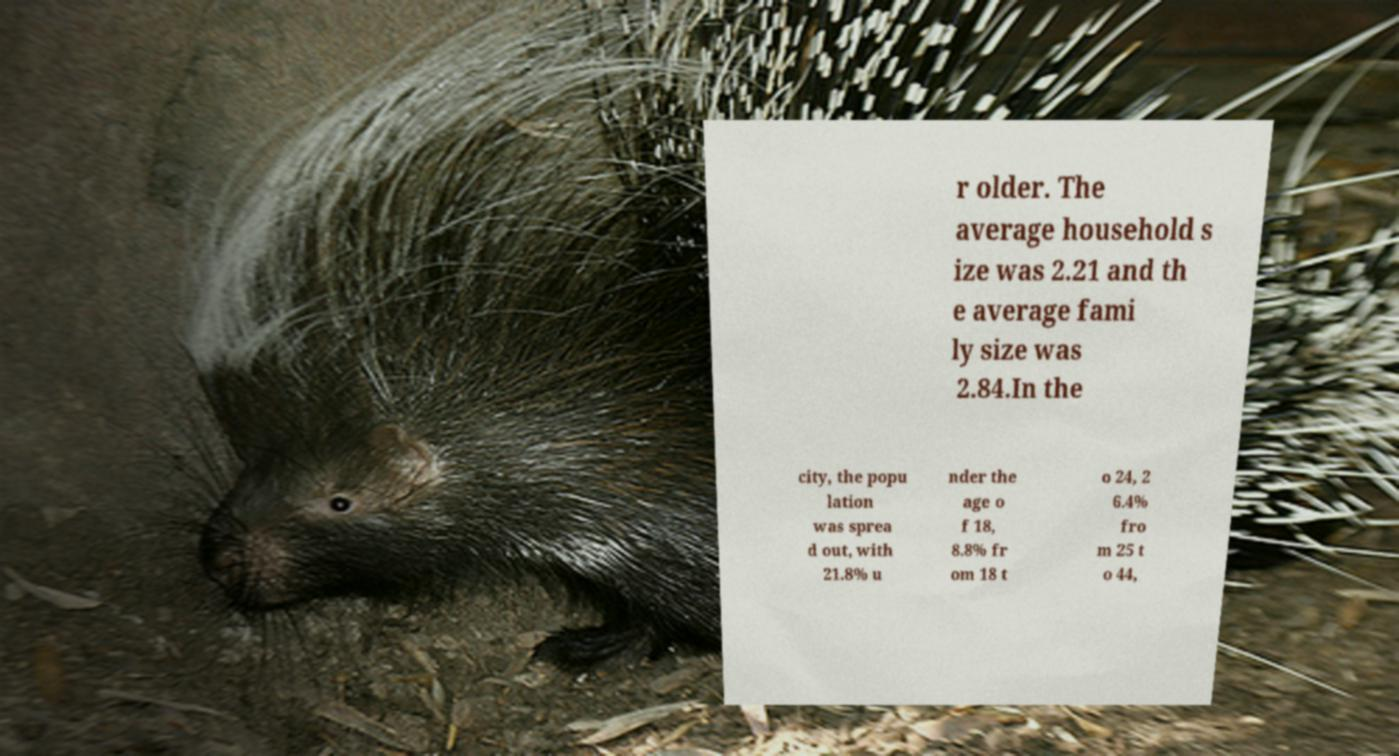What messages or text are displayed in this image? I need them in a readable, typed format. r older. The average household s ize was 2.21 and th e average fami ly size was 2.84.In the city, the popu lation was sprea d out, with 21.8% u nder the age o f 18, 8.8% fr om 18 t o 24, 2 6.4% fro m 25 t o 44, 